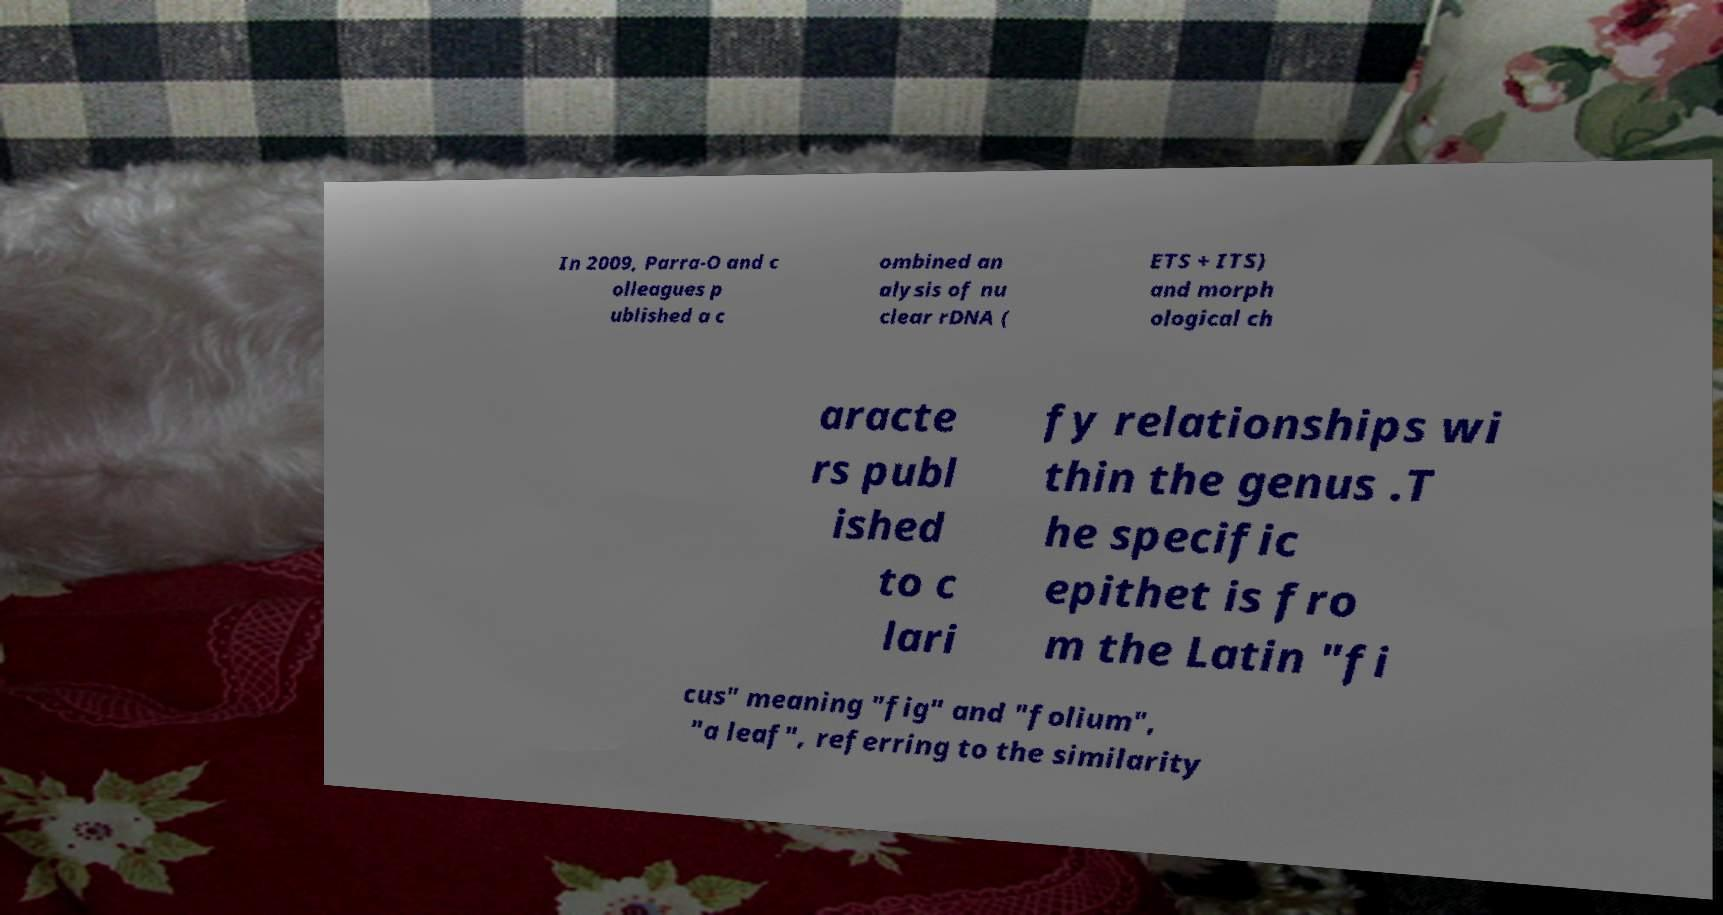Can you read and provide the text displayed in the image?This photo seems to have some interesting text. Can you extract and type it out for me? In 2009, Parra-O and c olleagues p ublished a c ombined an alysis of nu clear rDNA ( ETS + ITS) and morph ological ch aracte rs publ ished to c lari fy relationships wi thin the genus .T he specific epithet is fro m the Latin "fi cus" meaning "fig" and "folium", "a leaf", referring to the similarity 